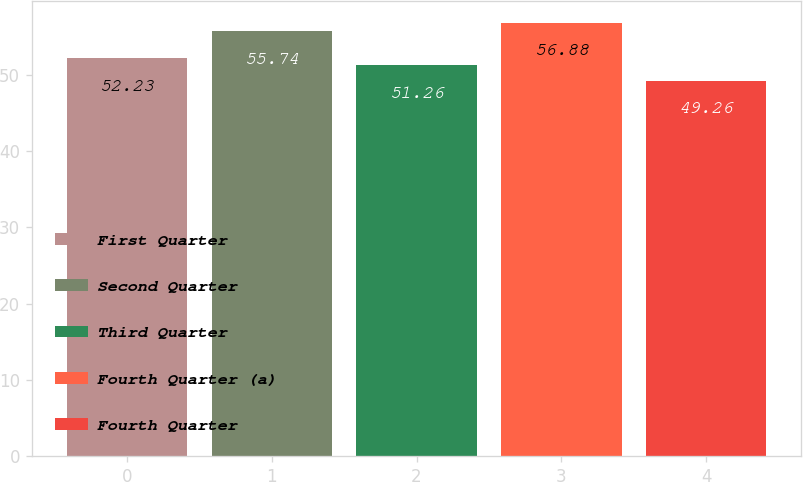<chart> <loc_0><loc_0><loc_500><loc_500><bar_chart><fcel>First Quarter<fcel>Second Quarter<fcel>Third Quarter<fcel>Fourth Quarter (a)<fcel>Fourth Quarter<nl><fcel>52.23<fcel>55.74<fcel>51.26<fcel>56.88<fcel>49.26<nl></chart> 